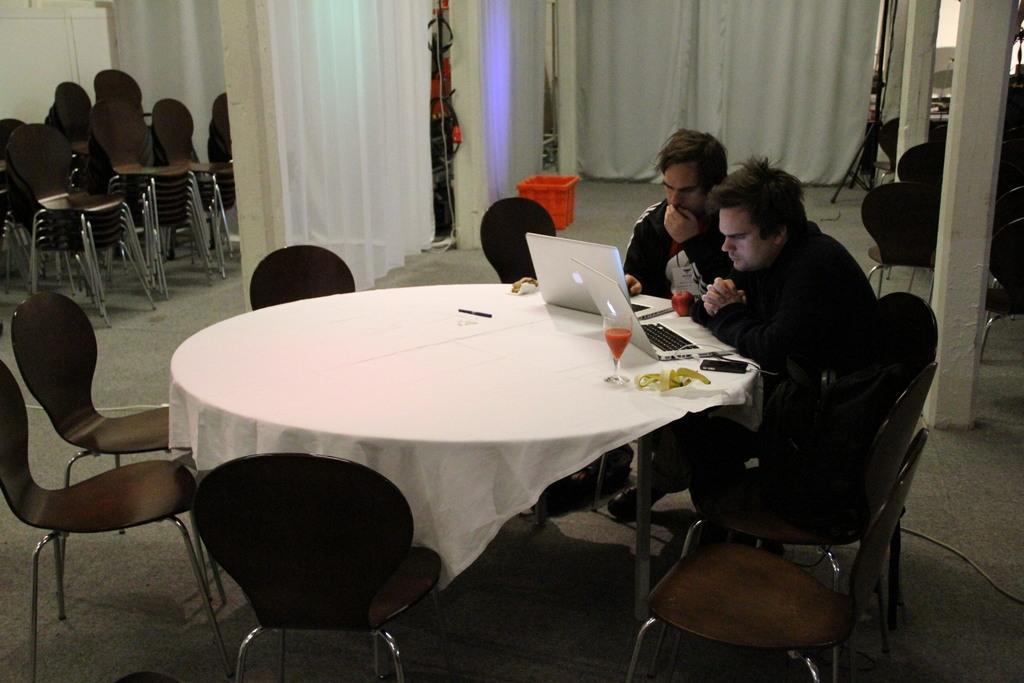Please provide a concise description of this image. In this picture we can see two persons sitting on a chair and looking into the laptop. This is a table. these are chairs. We can see a glass of drink on the table. On the background of the picture we can see white curtains and these are the chairs. This is a floor. 